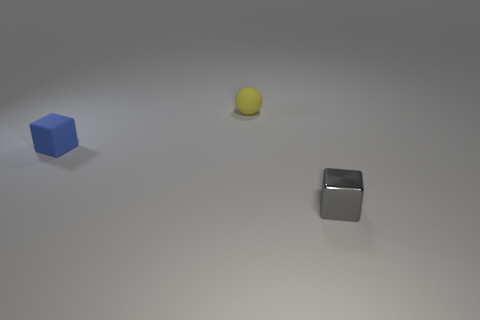There is a blue cube that is the same size as the gray object; what is its material?
Ensure brevity in your answer.  Rubber. Is there a brown matte object of the same size as the gray metallic cube?
Keep it short and to the point. No. There is a block that is on the left side of the yellow rubber thing; does it have the same size as the small shiny thing?
Your response must be concise. Yes. There is a thing that is to the left of the small metallic cube and in front of the tiny yellow sphere; what is its shape?
Offer a terse response. Cube. Is the number of rubber blocks in front of the tiny metal block greater than the number of large brown rubber cubes?
Ensure brevity in your answer.  No. What is the size of the cube that is made of the same material as the tiny yellow object?
Provide a succinct answer. Small. What number of tiny cubes are the same color as the tiny ball?
Your answer should be compact. 0. Does the block to the left of the gray cube have the same color as the sphere?
Provide a succinct answer. No. Are there the same number of tiny rubber objects on the left side of the tiny yellow rubber ball and gray shiny things on the left side of the tiny gray metallic object?
Your answer should be compact. No. Are there any other things that are the same material as the gray cube?
Keep it short and to the point. No. 